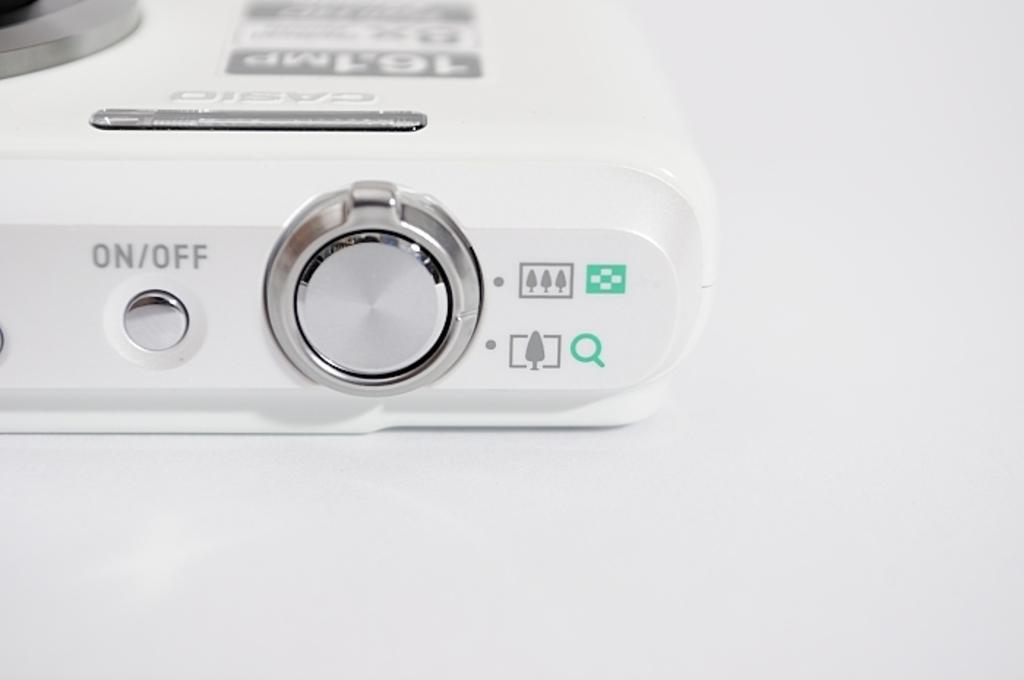<image>
Present a compact description of the photo's key features. The electrical device shown has a silver on/off button. 